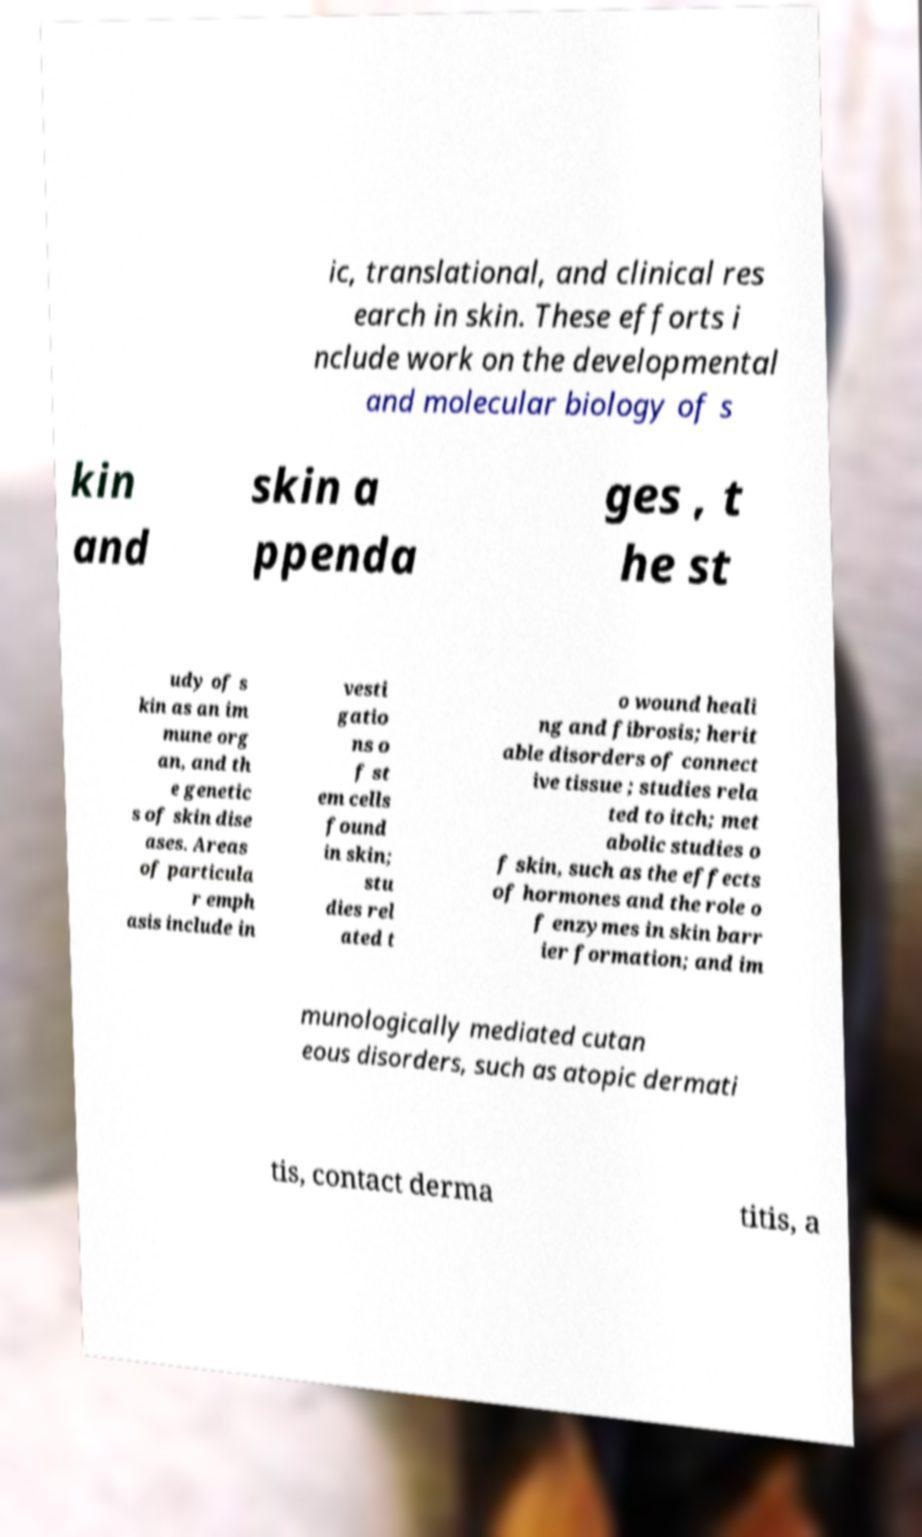Could you assist in decoding the text presented in this image and type it out clearly? ic, translational, and clinical res earch in skin. These efforts i nclude work on the developmental and molecular biology of s kin and skin a ppenda ges , t he st udy of s kin as an im mune org an, and th e genetic s of skin dise ases. Areas of particula r emph asis include in vesti gatio ns o f st em cells found in skin; stu dies rel ated t o wound heali ng and fibrosis; herit able disorders of connect ive tissue ; studies rela ted to itch; met abolic studies o f skin, such as the effects of hormones and the role o f enzymes in skin barr ier formation; and im munologically mediated cutan eous disorders, such as atopic dermati tis, contact derma titis, a 